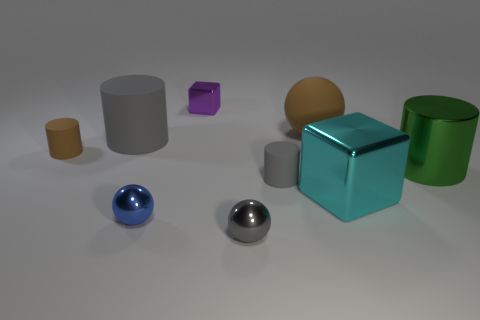Are the tiny gray cylinder and the cyan cube made of the same material?
Your answer should be very brief. No. Are there any large matte balls in front of the gray shiny thing?
Keep it short and to the point. No. The small gray thing behind the metallic cube that is right of the big brown rubber sphere is made of what material?
Your response must be concise. Rubber. What is the size of the other object that is the same shape as the cyan shiny object?
Make the answer very short. Small. Is the tiny block the same color as the metal cylinder?
Ensure brevity in your answer.  No. There is a small thing that is both in front of the cyan metallic thing and on the right side of the blue shiny object; what color is it?
Your answer should be compact. Gray. There is a cube that is behind the cyan thing; is it the same size as the large green thing?
Your response must be concise. No. Is there any other thing that is the same shape as the big gray thing?
Your response must be concise. Yes. Do the large green thing and the cylinder behind the brown matte cylinder have the same material?
Keep it short and to the point. No. What number of gray things are metal balls or large spheres?
Your response must be concise. 1. 